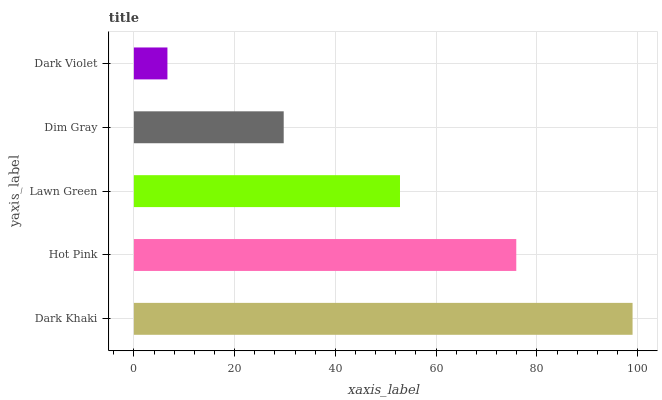Is Dark Violet the minimum?
Answer yes or no. Yes. Is Dark Khaki the maximum?
Answer yes or no. Yes. Is Hot Pink the minimum?
Answer yes or no. No. Is Hot Pink the maximum?
Answer yes or no. No. Is Dark Khaki greater than Hot Pink?
Answer yes or no. Yes. Is Hot Pink less than Dark Khaki?
Answer yes or no. Yes. Is Hot Pink greater than Dark Khaki?
Answer yes or no. No. Is Dark Khaki less than Hot Pink?
Answer yes or no. No. Is Lawn Green the high median?
Answer yes or no. Yes. Is Lawn Green the low median?
Answer yes or no. Yes. Is Hot Pink the high median?
Answer yes or no. No. Is Dark Khaki the low median?
Answer yes or no. No. 